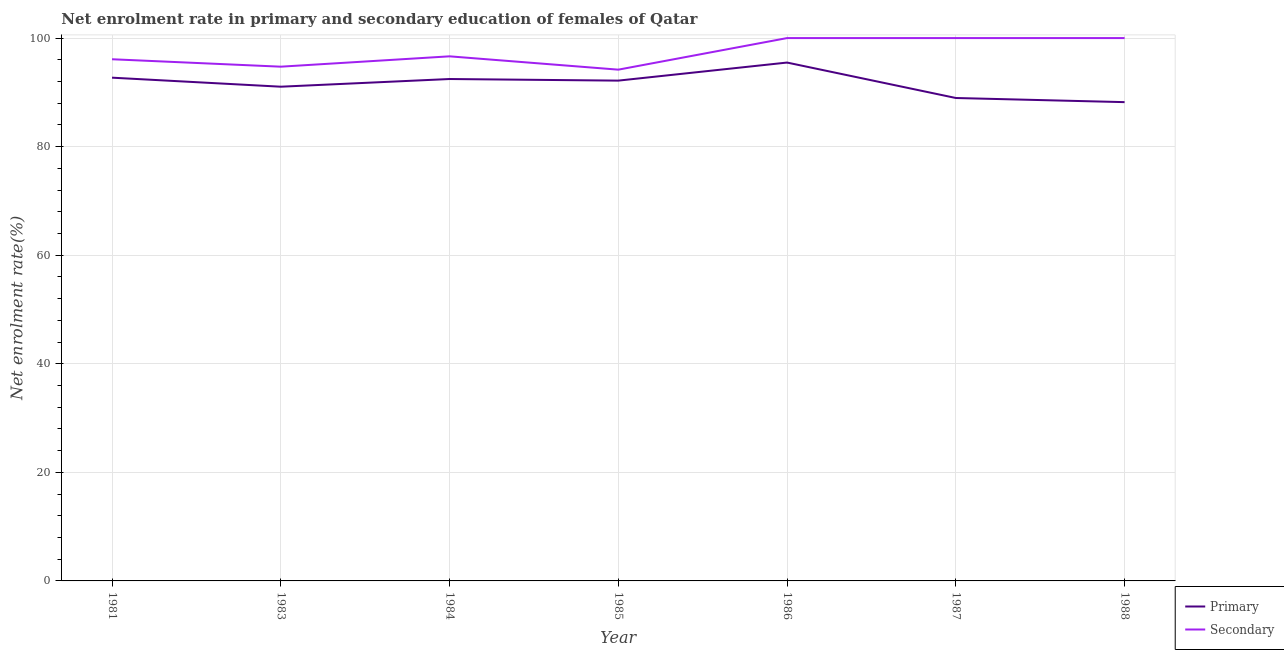Does the line corresponding to enrollment rate in primary education intersect with the line corresponding to enrollment rate in secondary education?
Your answer should be very brief. No. Is the number of lines equal to the number of legend labels?
Offer a terse response. Yes. What is the enrollment rate in primary education in 1983?
Give a very brief answer. 91.04. Across all years, what is the maximum enrollment rate in primary education?
Provide a short and direct response. 95.49. Across all years, what is the minimum enrollment rate in primary education?
Your answer should be compact. 88.2. What is the total enrollment rate in primary education in the graph?
Provide a short and direct response. 641.02. What is the difference between the enrollment rate in primary education in 1983 and that in 1986?
Your answer should be very brief. -4.45. What is the difference between the enrollment rate in secondary education in 1987 and the enrollment rate in primary education in 1984?
Ensure brevity in your answer.  7.54. What is the average enrollment rate in primary education per year?
Give a very brief answer. 91.57. In the year 1988, what is the difference between the enrollment rate in secondary education and enrollment rate in primary education?
Give a very brief answer. 11.8. In how many years, is the enrollment rate in secondary education greater than 40 %?
Give a very brief answer. 7. What is the ratio of the enrollment rate in secondary education in 1983 to that in 1986?
Offer a very short reply. 0.95. What is the difference between the highest and the lowest enrollment rate in primary education?
Provide a succinct answer. 7.29. In how many years, is the enrollment rate in secondary education greater than the average enrollment rate in secondary education taken over all years?
Make the answer very short. 3. Is the enrollment rate in primary education strictly greater than the enrollment rate in secondary education over the years?
Offer a very short reply. No. How many lines are there?
Your answer should be compact. 2. Are the values on the major ticks of Y-axis written in scientific E-notation?
Keep it short and to the point. No. Does the graph contain any zero values?
Provide a succinct answer. No. How many legend labels are there?
Your answer should be very brief. 2. What is the title of the graph?
Your answer should be very brief. Net enrolment rate in primary and secondary education of females of Qatar. Does "Domestic Liabilities" appear as one of the legend labels in the graph?
Offer a very short reply. No. What is the label or title of the X-axis?
Keep it short and to the point. Year. What is the label or title of the Y-axis?
Give a very brief answer. Net enrolment rate(%). What is the Net enrolment rate(%) in Primary in 1981?
Keep it short and to the point. 92.71. What is the Net enrolment rate(%) of Secondary in 1981?
Provide a succinct answer. 96.1. What is the Net enrolment rate(%) in Primary in 1983?
Keep it short and to the point. 91.04. What is the Net enrolment rate(%) in Secondary in 1983?
Provide a short and direct response. 94.73. What is the Net enrolment rate(%) in Primary in 1984?
Give a very brief answer. 92.46. What is the Net enrolment rate(%) in Secondary in 1984?
Your response must be concise. 96.64. What is the Net enrolment rate(%) in Primary in 1985?
Offer a terse response. 92.16. What is the Net enrolment rate(%) in Secondary in 1985?
Offer a very short reply. 94.18. What is the Net enrolment rate(%) of Primary in 1986?
Your answer should be very brief. 95.49. What is the Net enrolment rate(%) of Primary in 1987?
Your answer should be very brief. 88.96. What is the Net enrolment rate(%) of Secondary in 1987?
Offer a terse response. 100. What is the Net enrolment rate(%) of Primary in 1988?
Ensure brevity in your answer.  88.2. Across all years, what is the maximum Net enrolment rate(%) in Primary?
Provide a short and direct response. 95.49. Across all years, what is the minimum Net enrolment rate(%) in Primary?
Offer a very short reply. 88.2. Across all years, what is the minimum Net enrolment rate(%) of Secondary?
Your response must be concise. 94.18. What is the total Net enrolment rate(%) of Primary in the graph?
Your answer should be compact. 641.02. What is the total Net enrolment rate(%) in Secondary in the graph?
Your answer should be very brief. 681.65. What is the difference between the Net enrolment rate(%) of Primary in 1981 and that in 1983?
Make the answer very short. 1.66. What is the difference between the Net enrolment rate(%) in Secondary in 1981 and that in 1983?
Keep it short and to the point. 1.37. What is the difference between the Net enrolment rate(%) in Primary in 1981 and that in 1984?
Offer a very short reply. 0.25. What is the difference between the Net enrolment rate(%) of Secondary in 1981 and that in 1984?
Provide a succinct answer. -0.54. What is the difference between the Net enrolment rate(%) of Primary in 1981 and that in 1985?
Ensure brevity in your answer.  0.54. What is the difference between the Net enrolment rate(%) of Secondary in 1981 and that in 1985?
Keep it short and to the point. 1.92. What is the difference between the Net enrolment rate(%) of Primary in 1981 and that in 1986?
Offer a very short reply. -2.79. What is the difference between the Net enrolment rate(%) in Secondary in 1981 and that in 1986?
Give a very brief answer. -3.9. What is the difference between the Net enrolment rate(%) in Primary in 1981 and that in 1987?
Provide a succinct answer. 3.74. What is the difference between the Net enrolment rate(%) of Secondary in 1981 and that in 1987?
Provide a short and direct response. -3.9. What is the difference between the Net enrolment rate(%) of Primary in 1981 and that in 1988?
Your response must be concise. 4.51. What is the difference between the Net enrolment rate(%) in Secondary in 1981 and that in 1988?
Provide a succinct answer. -3.9. What is the difference between the Net enrolment rate(%) of Primary in 1983 and that in 1984?
Your answer should be very brief. -1.42. What is the difference between the Net enrolment rate(%) of Secondary in 1983 and that in 1984?
Keep it short and to the point. -1.91. What is the difference between the Net enrolment rate(%) in Primary in 1983 and that in 1985?
Provide a short and direct response. -1.12. What is the difference between the Net enrolment rate(%) of Secondary in 1983 and that in 1985?
Ensure brevity in your answer.  0.55. What is the difference between the Net enrolment rate(%) of Primary in 1983 and that in 1986?
Provide a succinct answer. -4.45. What is the difference between the Net enrolment rate(%) in Secondary in 1983 and that in 1986?
Ensure brevity in your answer.  -5.27. What is the difference between the Net enrolment rate(%) in Primary in 1983 and that in 1987?
Your answer should be compact. 2.08. What is the difference between the Net enrolment rate(%) of Secondary in 1983 and that in 1987?
Provide a short and direct response. -5.27. What is the difference between the Net enrolment rate(%) in Primary in 1983 and that in 1988?
Make the answer very short. 2.84. What is the difference between the Net enrolment rate(%) in Secondary in 1983 and that in 1988?
Keep it short and to the point. -5.27. What is the difference between the Net enrolment rate(%) in Primary in 1984 and that in 1985?
Give a very brief answer. 0.29. What is the difference between the Net enrolment rate(%) of Secondary in 1984 and that in 1985?
Provide a succinct answer. 2.46. What is the difference between the Net enrolment rate(%) of Primary in 1984 and that in 1986?
Your answer should be compact. -3.03. What is the difference between the Net enrolment rate(%) of Secondary in 1984 and that in 1986?
Give a very brief answer. -3.36. What is the difference between the Net enrolment rate(%) in Primary in 1984 and that in 1987?
Provide a succinct answer. 3.5. What is the difference between the Net enrolment rate(%) of Secondary in 1984 and that in 1987?
Give a very brief answer. -3.36. What is the difference between the Net enrolment rate(%) of Primary in 1984 and that in 1988?
Give a very brief answer. 4.26. What is the difference between the Net enrolment rate(%) in Secondary in 1984 and that in 1988?
Offer a terse response. -3.36. What is the difference between the Net enrolment rate(%) in Primary in 1985 and that in 1986?
Your response must be concise. -3.33. What is the difference between the Net enrolment rate(%) of Secondary in 1985 and that in 1986?
Keep it short and to the point. -5.82. What is the difference between the Net enrolment rate(%) of Primary in 1985 and that in 1987?
Your answer should be compact. 3.2. What is the difference between the Net enrolment rate(%) in Secondary in 1985 and that in 1987?
Give a very brief answer. -5.82. What is the difference between the Net enrolment rate(%) in Primary in 1985 and that in 1988?
Your answer should be very brief. 3.96. What is the difference between the Net enrolment rate(%) in Secondary in 1985 and that in 1988?
Keep it short and to the point. -5.82. What is the difference between the Net enrolment rate(%) of Primary in 1986 and that in 1987?
Your response must be concise. 6.53. What is the difference between the Net enrolment rate(%) of Primary in 1986 and that in 1988?
Ensure brevity in your answer.  7.29. What is the difference between the Net enrolment rate(%) of Primary in 1987 and that in 1988?
Your answer should be very brief. 0.76. What is the difference between the Net enrolment rate(%) in Secondary in 1987 and that in 1988?
Ensure brevity in your answer.  0. What is the difference between the Net enrolment rate(%) in Primary in 1981 and the Net enrolment rate(%) in Secondary in 1983?
Your response must be concise. -2.03. What is the difference between the Net enrolment rate(%) in Primary in 1981 and the Net enrolment rate(%) in Secondary in 1984?
Offer a terse response. -3.93. What is the difference between the Net enrolment rate(%) in Primary in 1981 and the Net enrolment rate(%) in Secondary in 1985?
Make the answer very short. -1.48. What is the difference between the Net enrolment rate(%) in Primary in 1981 and the Net enrolment rate(%) in Secondary in 1986?
Provide a succinct answer. -7.29. What is the difference between the Net enrolment rate(%) of Primary in 1981 and the Net enrolment rate(%) of Secondary in 1987?
Offer a very short reply. -7.29. What is the difference between the Net enrolment rate(%) in Primary in 1981 and the Net enrolment rate(%) in Secondary in 1988?
Your answer should be very brief. -7.29. What is the difference between the Net enrolment rate(%) of Primary in 1983 and the Net enrolment rate(%) of Secondary in 1984?
Provide a succinct answer. -5.6. What is the difference between the Net enrolment rate(%) in Primary in 1983 and the Net enrolment rate(%) in Secondary in 1985?
Your response must be concise. -3.14. What is the difference between the Net enrolment rate(%) in Primary in 1983 and the Net enrolment rate(%) in Secondary in 1986?
Offer a very short reply. -8.96. What is the difference between the Net enrolment rate(%) of Primary in 1983 and the Net enrolment rate(%) of Secondary in 1987?
Offer a very short reply. -8.96. What is the difference between the Net enrolment rate(%) of Primary in 1983 and the Net enrolment rate(%) of Secondary in 1988?
Your answer should be very brief. -8.96. What is the difference between the Net enrolment rate(%) of Primary in 1984 and the Net enrolment rate(%) of Secondary in 1985?
Provide a succinct answer. -1.73. What is the difference between the Net enrolment rate(%) of Primary in 1984 and the Net enrolment rate(%) of Secondary in 1986?
Provide a short and direct response. -7.54. What is the difference between the Net enrolment rate(%) in Primary in 1984 and the Net enrolment rate(%) in Secondary in 1987?
Keep it short and to the point. -7.54. What is the difference between the Net enrolment rate(%) of Primary in 1984 and the Net enrolment rate(%) of Secondary in 1988?
Offer a terse response. -7.54. What is the difference between the Net enrolment rate(%) of Primary in 1985 and the Net enrolment rate(%) of Secondary in 1986?
Provide a short and direct response. -7.84. What is the difference between the Net enrolment rate(%) in Primary in 1985 and the Net enrolment rate(%) in Secondary in 1987?
Offer a terse response. -7.84. What is the difference between the Net enrolment rate(%) in Primary in 1985 and the Net enrolment rate(%) in Secondary in 1988?
Make the answer very short. -7.84. What is the difference between the Net enrolment rate(%) in Primary in 1986 and the Net enrolment rate(%) in Secondary in 1987?
Give a very brief answer. -4.51. What is the difference between the Net enrolment rate(%) of Primary in 1986 and the Net enrolment rate(%) of Secondary in 1988?
Offer a terse response. -4.51. What is the difference between the Net enrolment rate(%) in Primary in 1987 and the Net enrolment rate(%) in Secondary in 1988?
Provide a succinct answer. -11.04. What is the average Net enrolment rate(%) of Primary per year?
Your answer should be very brief. 91.57. What is the average Net enrolment rate(%) of Secondary per year?
Your answer should be very brief. 97.38. In the year 1981, what is the difference between the Net enrolment rate(%) of Primary and Net enrolment rate(%) of Secondary?
Provide a short and direct response. -3.39. In the year 1983, what is the difference between the Net enrolment rate(%) in Primary and Net enrolment rate(%) in Secondary?
Provide a short and direct response. -3.69. In the year 1984, what is the difference between the Net enrolment rate(%) in Primary and Net enrolment rate(%) in Secondary?
Provide a short and direct response. -4.18. In the year 1985, what is the difference between the Net enrolment rate(%) in Primary and Net enrolment rate(%) in Secondary?
Your answer should be very brief. -2.02. In the year 1986, what is the difference between the Net enrolment rate(%) in Primary and Net enrolment rate(%) in Secondary?
Your answer should be very brief. -4.51. In the year 1987, what is the difference between the Net enrolment rate(%) in Primary and Net enrolment rate(%) in Secondary?
Offer a very short reply. -11.04. In the year 1988, what is the difference between the Net enrolment rate(%) in Primary and Net enrolment rate(%) in Secondary?
Offer a very short reply. -11.8. What is the ratio of the Net enrolment rate(%) in Primary in 1981 to that in 1983?
Your response must be concise. 1.02. What is the ratio of the Net enrolment rate(%) of Secondary in 1981 to that in 1983?
Make the answer very short. 1.01. What is the ratio of the Net enrolment rate(%) of Primary in 1981 to that in 1984?
Your response must be concise. 1. What is the ratio of the Net enrolment rate(%) in Secondary in 1981 to that in 1984?
Make the answer very short. 0.99. What is the ratio of the Net enrolment rate(%) in Primary in 1981 to that in 1985?
Ensure brevity in your answer.  1.01. What is the ratio of the Net enrolment rate(%) of Secondary in 1981 to that in 1985?
Provide a succinct answer. 1.02. What is the ratio of the Net enrolment rate(%) in Primary in 1981 to that in 1986?
Make the answer very short. 0.97. What is the ratio of the Net enrolment rate(%) in Secondary in 1981 to that in 1986?
Provide a succinct answer. 0.96. What is the ratio of the Net enrolment rate(%) of Primary in 1981 to that in 1987?
Offer a terse response. 1.04. What is the ratio of the Net enrolment rate(%) of Secondary in 1981 to that in 1987?
Provide a succinct answer. 0.96. What is the ratio of the Net enrolment rate(%) of Primary in 1981 to that in 1988?
Offer a terse response. 1.05. What is the ratio of the Net enrolment rate(%) in Primary in 1983 to that in 1984?
Your response must be concise. 0.98. What is the ratio of the Net enrolment rate(%) in Secondary in 1983 to that in 1984?
Make the answer very short. 0.98. What is the ratio of the Net enrolment rate(%) in Secondary in 1983 to that in 1985?
Your answer should be very brief. 1.01. What is the ratio of the Net enrolment rate(%) in Primary in 1983 to that in 1986?
Make the answer very short. 0.95. What is the ratio of the Net enrolment rate(%) in Secondary in 1983 to that in 1986?
Ensure brevity in your answer.  0.95. What is the ratio of the Net enrolment rate(%) in Primary in 1983 to that in 1987?
Keep it short and to the point. 1.02. What is the ratio of the Net enrolment rate(%) of Secondary in 1983 to that in 1987?
Offer a terse response. 0.95. What is the ratio of the Net enrolment rate(%) of Primary in 1983 to that in 1988?
Your answer should be compact. 1.03. What is the ratio of the Net enrolment rate(%) in Secondary in 1983 to that in 1988?
Offer a terse response. 0.95. What is the ratio of the Net enrolment rate(%) in Primary in 1984 to that in 1985?
Give a very brief answer. 1. What is the ratio of the Net enrolment rate(%) of Secondary in 1984 to that in 1985?
Make the answer very short. 1.03. What is the ratio of the Net enrolment rate(%) in Primary in 1984 to that in 1986?
Offer a terse response. 0.97. What is the ratio of the Net enrolment rate(%) of Secondary in 1984 to that in 1986?
Provide a short and direct response. 0.97. What is the ratio of the Net enrolment rate(%) in Primary in 1984 to that in 1987?
Your answer should be compact. 1.04. What is the ratio of the Net enrolment rate(%) of Secondary in 1984 to that in 1987?
Provide a succinct answer. 0.97. What is the ratio of the Net enrolment rate(%) of Primary in 1984 to that in 1988?
Your answer should be very brief. 1.05. What is the ratio of the Net enrolment rate(%) in Secondary in 1984 to that in 1988?
Your response must be concise. 0.97. What is the ratio of the Net enrolment rate(%) of Primary in 1985 to that in 1986?
Provide a short and direct response. 0.97. What is the ratio of the Net enrolment rate(%) of Secondary in 1985 to that in 1986?
Offer a terse response. 0.94. What is the ratio of the Net enrolment rate(%) of Primary in 1985 to that in 1987?
Make the answer very short. 1.04. What is the ratio of the Net enrolment rate(%) of Secondary in 1985 to that in 1987?
Give a very brief answer. 0.94. What is the ratio of the Net enrolment rate(%) of Primary in 1985 to that in 1988?
Your response must be concise. 1.04. What is the ratio of the Net enrolment rate(%) in Secondary in 1985 to that in 1988?
Make the answer very short. 0.94. What is the ratio of the Net enrolment rate(%) of Primary in 1986 to that in 1987?
Offer a very short reply. 1.07. What is the ratio of the Net enrolment rate(%) of Secondary in 1986 to that in 1987?
Provide a succinct answer. 1. What is the ratio of the Net enrolment rate(%) of Primary in 1986 to that in 1988?
Provide a short and direct response. 1.08. What is the ratio of the Net enrolment rate(%) in Primary in 1987 to that in 1988?
Ensure brevity in your answer.  1.01. What is the difference between the highest and the second highest Net enrolment rate(%) of Primary?
Offer a very short reply. 2.79. What is the difference between the highest and the lowest Net enrolment rate(%) in Primary?
Provide a succinct answer. 7.29. What is the difference between the highest and the lowest Net enrolment rate(%) in Secondary?
Make the answer very short. 5.82. 